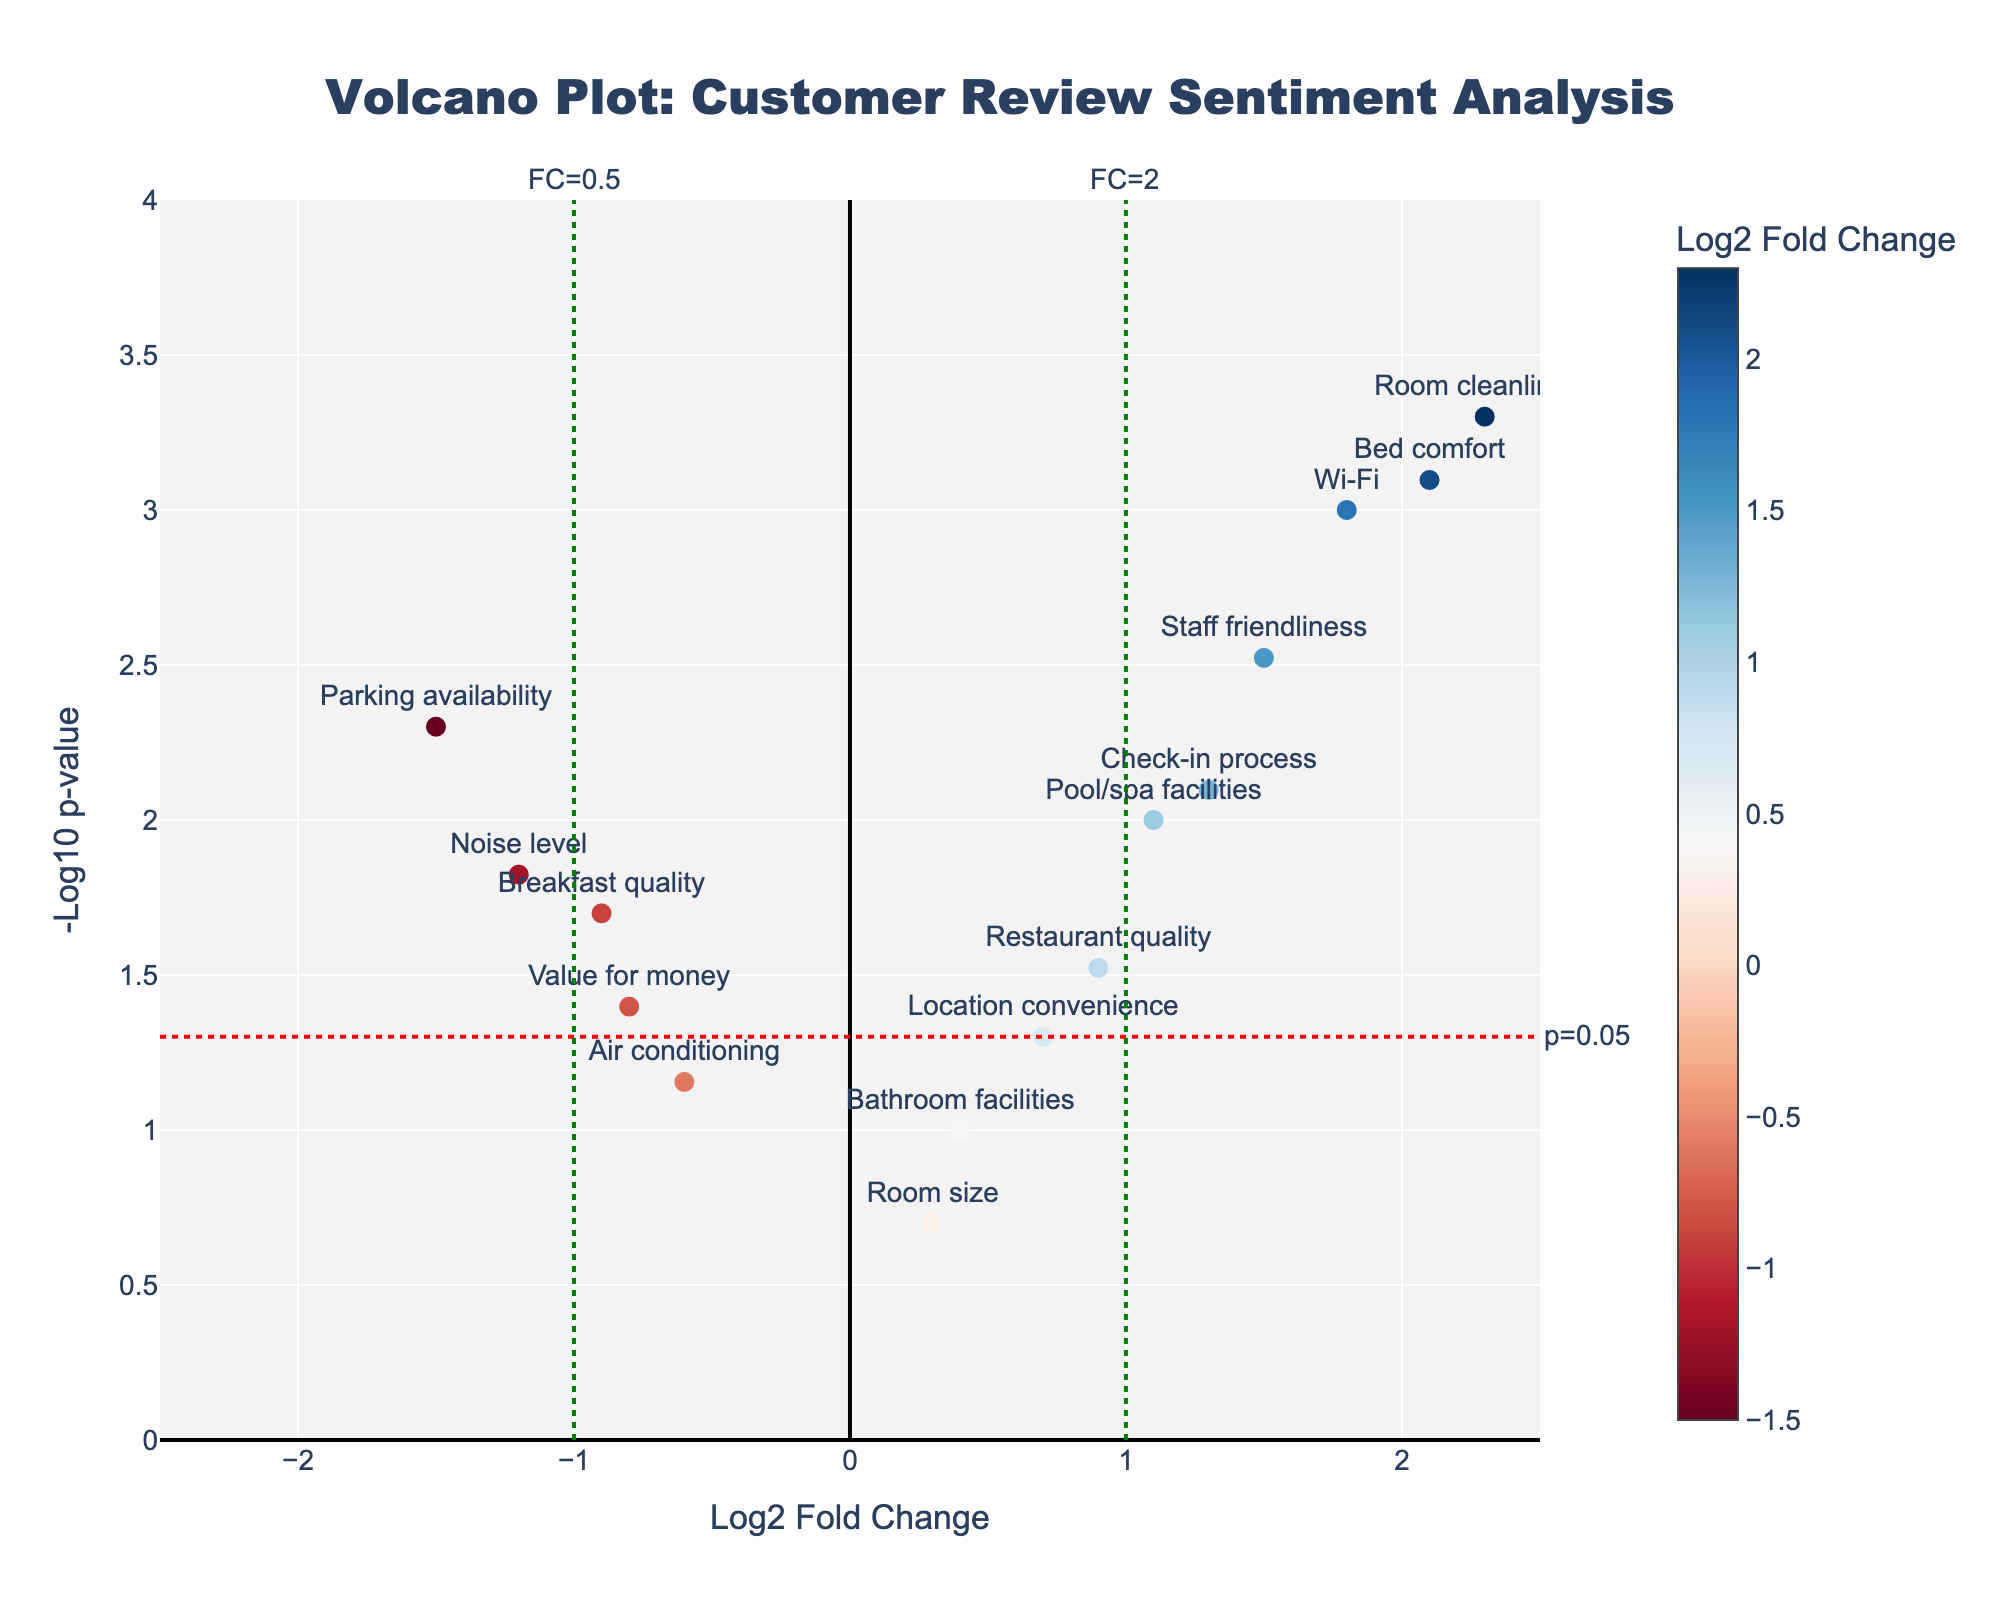What is the title of the volcano plot? The title is displayed at the top of the figure, centered and in large text, indicating the main subject of the plot, which helps in understanding the context of the data.
Answer: Volcano Plot: Customer Review Sentiment Analysis Which amenity has the highest log2 fold change? To find the amenity with the highest log2 fold change, look at the x-axis where the fold change values are plotted. The amenity with the furthest point to the right has the highest value.
Answer: Room cleanliness What is the log2 fold change and p-value for the 'Noise level' amenity? Locate 'Noise level' on the plot by hovering over or looking for the label. The x-coordinate gives the log2 fold change, and the y-coordinate (transformed to -log10 of the p-value) should be checked against the scale.
Answer: Log2 FC: -1.2, p-value: 0.015 How many amenities have a significantly different sentiment (p-value < 0.05)? Identify which points on the plot are above the horizontal red dashed line indicating p=0.05. Count these points to determine the number of significant amenities.
Answer: 10 Which amenities are considered significant and show a negative sentiment (negative log2 fold change)? Look for points that are both above the horizontal red line and have negative x-values. These points represent amenities with significant negative sentiment. Identify their labels.
Answer: Breakfast quality, Noise level, Parking availability, and Value for money Which amenities have a log2 fold change close to zero and are not significant? Look near the center of the x-axis (near zero) and below the horizontal red line (for p-value > 0.05). Identify these points and their labels.
Answer: Bathroom facilities, Room size, Air conditioning, and Location convenience If you were to improve marketing for one amenity based on this plot, which one would you choose and why? Look for an amenity with a high positive log2 fold change and significant p-value, indicating strong positive sentiment. This shows an area where guests are highly satisfied, which is favorable for marketing.
Answer: Room cleanliness, because it has the highest positive sentiment and is statistically significant 